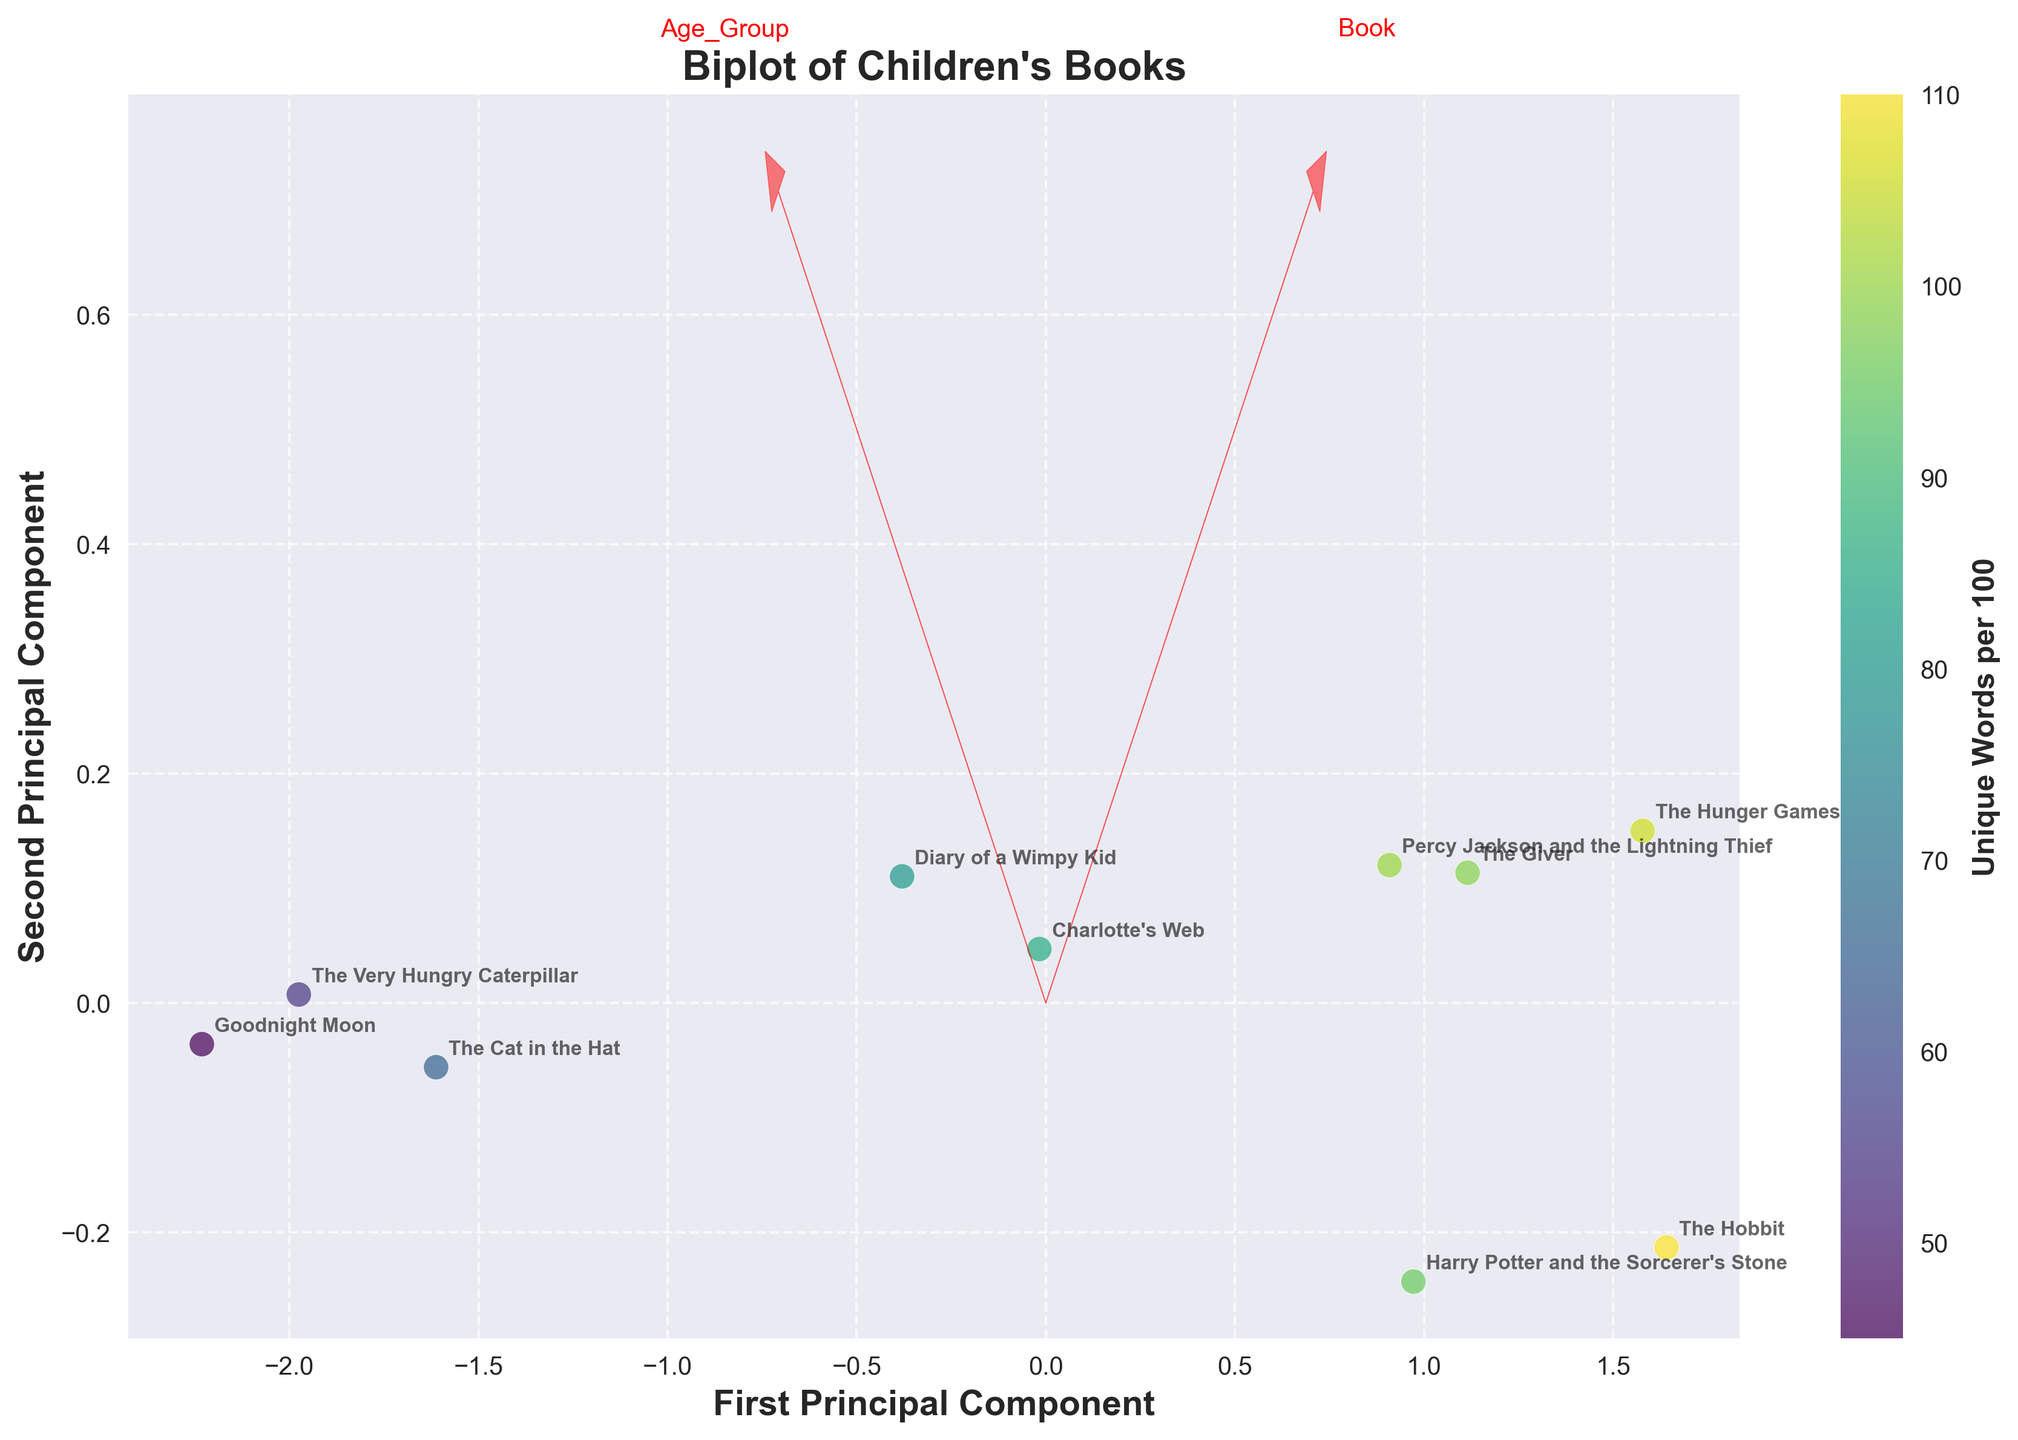What is the color used to represent 'Unique Words per 100' in the plot? The plot uses a color gradient (viridis color map) to represent the 'Unique Words per 100' on a color scale. You can see this from the colorbar added to the right of the plot.
Answer: Viridis gradient What are the labels of the two axes? The x-axis is labeled 'First Principal Component,' and the y-axis is labeled 'Second Principal Component.' These labels indicate the principal components derived through PCA.
Answer: First Principal Component, Second Principal Component Which book appears to have the highest Sentence Complexity based on its position relative to the feature vectors? By looking at the plot, 'The Hunger Games' is positioned farthest along the direction of the Sentence Complexity vector, which suggests it has a high Sentence Complexity.
Answer: The Hunger Games What age group does 'Goodnight Moon' belong to, and where is it placed on the plot? 'Goodnight Moon' belongs to the 0-3 age group and is positioned on the negative side of the first principal component and negative side of the second principal component, indicating lower values for the analyzed features.
Answer: 0-3, negative side for both PCs Which book has the highest 'Unique Words per 100' and where is it located in the plot? By referring to the color code, 'The Hobbit' has the highest value of 'Unique Words per 100' (110) and is probably located on the positive side of both principal components.
Answer: The Hobbit, positive side for both PCs Considering 'Harry Potter and the Sorcerer's Stone' and 'Diary of a Wimpy Kid', which book has a higher average word length? From the data in the plot, 'Harry Potter and the Sorcerer's Stone' has a higher average word length (4.8) compared to 'Diary of a Wimpy Kid' (4.0). This is indicated by its projection along the Avg_Word_Length feature vector.
Answer: Harry Potter and the Sorcerer's Stone Compare 'Charlotte's Web' and 'The Giver' in terms of Sentence Complexity and explain the difference. 'The Giver' is plotted farther along towards the positive direction of the Sentence Complexity vector than 'Charlotte's Web,' indicating that 'The Giver' has a higher Sentence Complexity.
Answer: The Giver has higher Sentence Complexity What's the primary feature influencing the first principal component based on the feature vectors drawn in the plot? By observing the direction and length of the feature vectors, the Avg_Word_Length vector has a greater influence on the first principal component, as it’s more aligned with PC1.
Answer: Avg_Word_Length Which book is closest to the origin (0,0) and what could this signify about its features? 'Diary of a Wimpy Kid' appears to be the closest to the origin. This suggests that its features (Avg_Word_Length and Sentence_Complexity) are near the mean values of the dataset.
Answer: Diary of a Wimpy Kid What's the trend in the relationship between age groups and sentence complexity? Observing the plot, books targeted at older age groups (e.g., 'The Hobbit,' 'The Giver,' 'The Hunger Games') are positioned farther along the Sentence Complexity vector compared to books for younger children (e.g., 'Goodnight Moon,' 'The Cat in the Hat'). This indicates that sentence complexity tends to increase with the intended reading age group.
Answer: Increases with age 